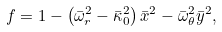<formula> <loc_0><loc_0><loc_500><loc_500>f = 1 - \left ( \bar { \omega } _ { r } ^ { 2 } - \bar { \kappa } _ { 0 } ^ { 2 } \right ) \bar { x } ^ { 2 } - \bar { \omega } _ { \theta } ^ { 2 } \bar { y } ^ { 2 } ,</formula> 